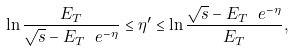<formula> <loc_0><loc_0><loc_500><loc_500>\ln { \frac { E _ { T } } { \sqrt { s } - E _ { T } \ e ^ { - \eta } } } \leq \eta ^ { \prime } \leq \ln { \frac { \sqrt { s } - E _ { T } \ e ^ { - \eta } } { E _ { T } } } ,</formula> 